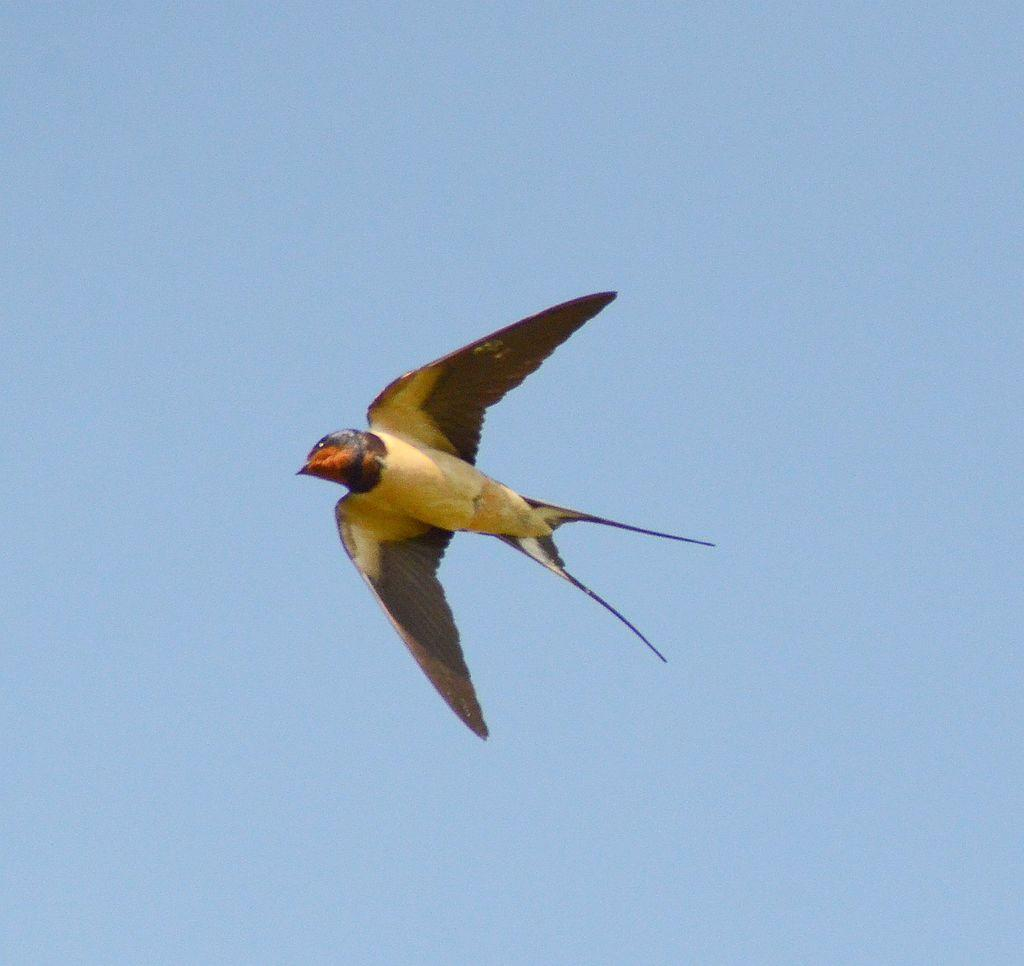What type of animal can be seen in the image? There is a bird in the image. What is the bird doing in the image? The bird is flying in the air. Can you describe the colors of the bird? The bird has yellow and brown colors. What is visible in the background of the image? There is sky visible in the background of the image. Where is the harbor located in the image? There is no harbor present in the image; it features a bird flying in the sky. What type of bear can be seen interacting with the bird in the image? There is no bear present in the image; it only features a bird flying in the sky. 